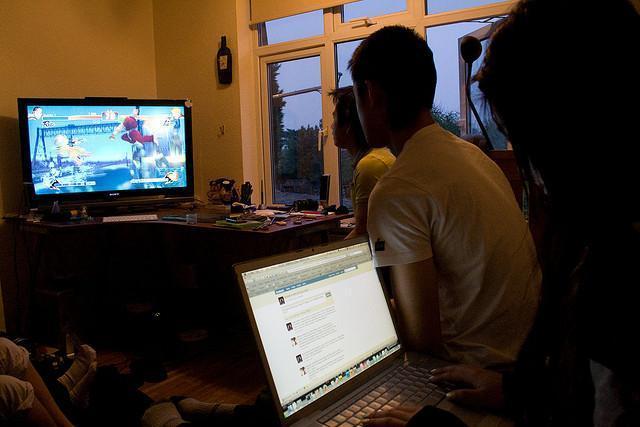How many computer screens?
Give a very brief answer. 1. How many people are visible?
Give a very brief answer. 4. 